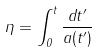<formula> <loc_0><loc_0><loc_500><loc_500>\eta = \int _ { 0 } ^ { t } \frac { d t ^ { \prime } } { a ( t ^ { \prime } ) }</formula> 